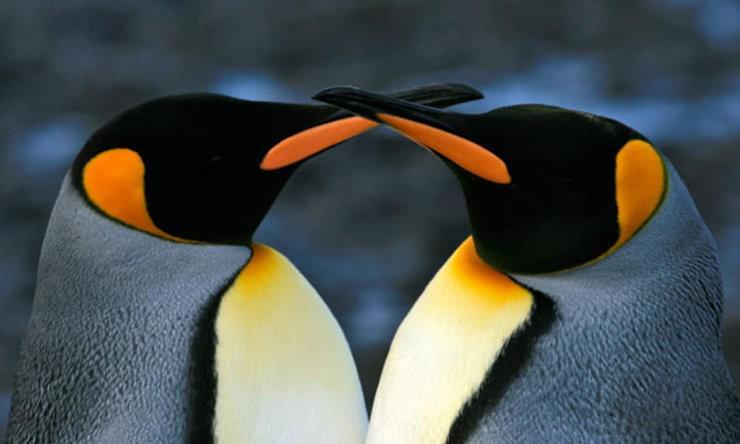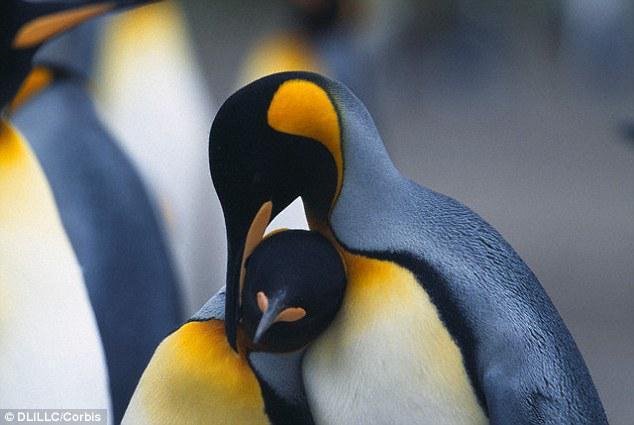The first image is the image on the left, the second image is the image on the right. Examine the images to the left and right. Is the description "There are two penguins facing the same direction in the left image." accurate? Answer yes or no. No. The first image is the image on the left, the second image is the image on the right. Examine the images to the left and right. Is the description "One penguin is touching another penguins beak with its beak." accurate? Answer yes or no. Yes. 